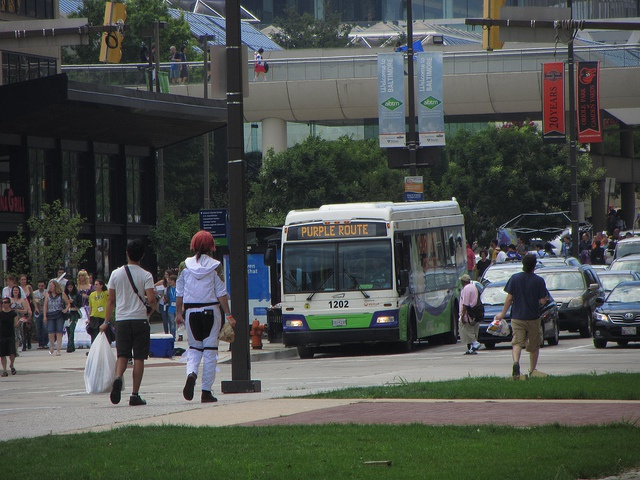Describe the objects in this image and their specific colors. I can see bus in black, gray, and darkgray tones, people in black, gray, darkgray, and maroon tones, people in black, darkgray, gray, and maroon tones, people in black, darkgray, and gray tones, and people in black and gray tones in this image. 